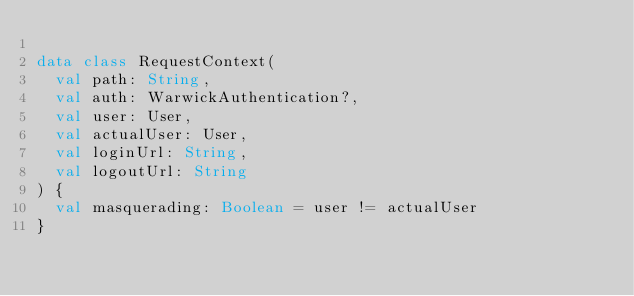<code> <loc_0><loc_0><loc_500><loc_500><_Kotlin_>
data class RequestContext(
  val path: String,
  val auth: WarwickAuthentication?,
  val user: User,
  val actualUser: User,
  val loginUrl: String,
  val logoutUrl: String
) {
  val masquerading: Boolean = user != actualUser
}
</code> 